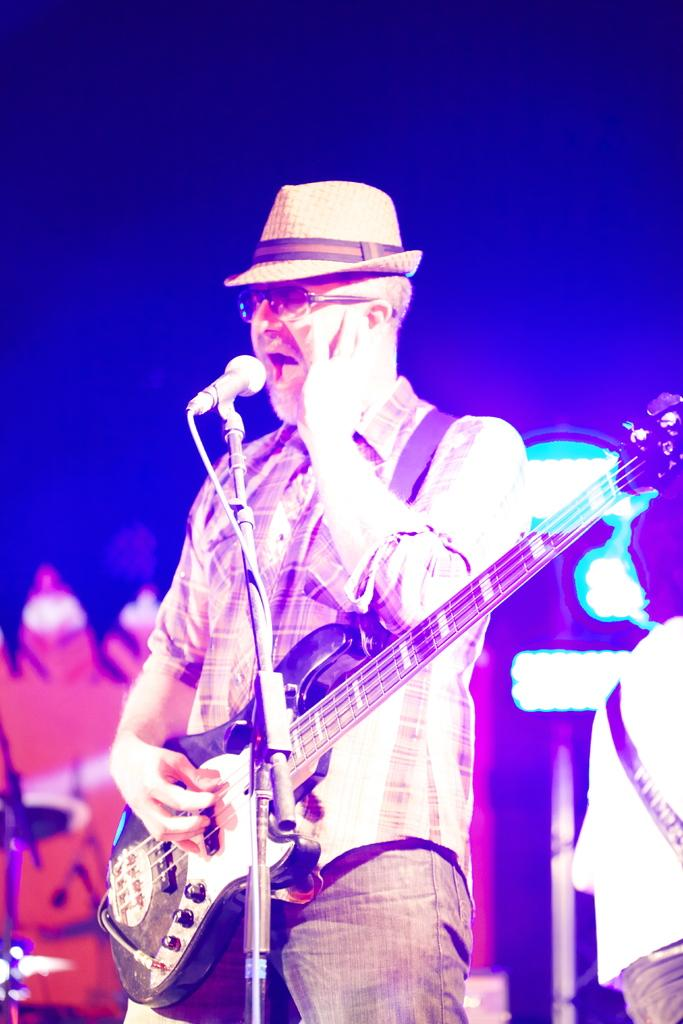Who is present in the image? There is a man in the image. What is the man wearing on his head? The man is wearing a hat. What is the man wearing to protect his eyes? The man is wearing goggles. What is the man holding in the image? The man is holding a guitar. What device is visible in the image that is used for amplifying sound? There is a microphone in the image. What type of holiday is being celebrated in the image? There is no indication of a holiday being celebrated in the image. What view can be seen in the background of the image? The image does not show a view in the background; it focuses on the man and his accessories. 